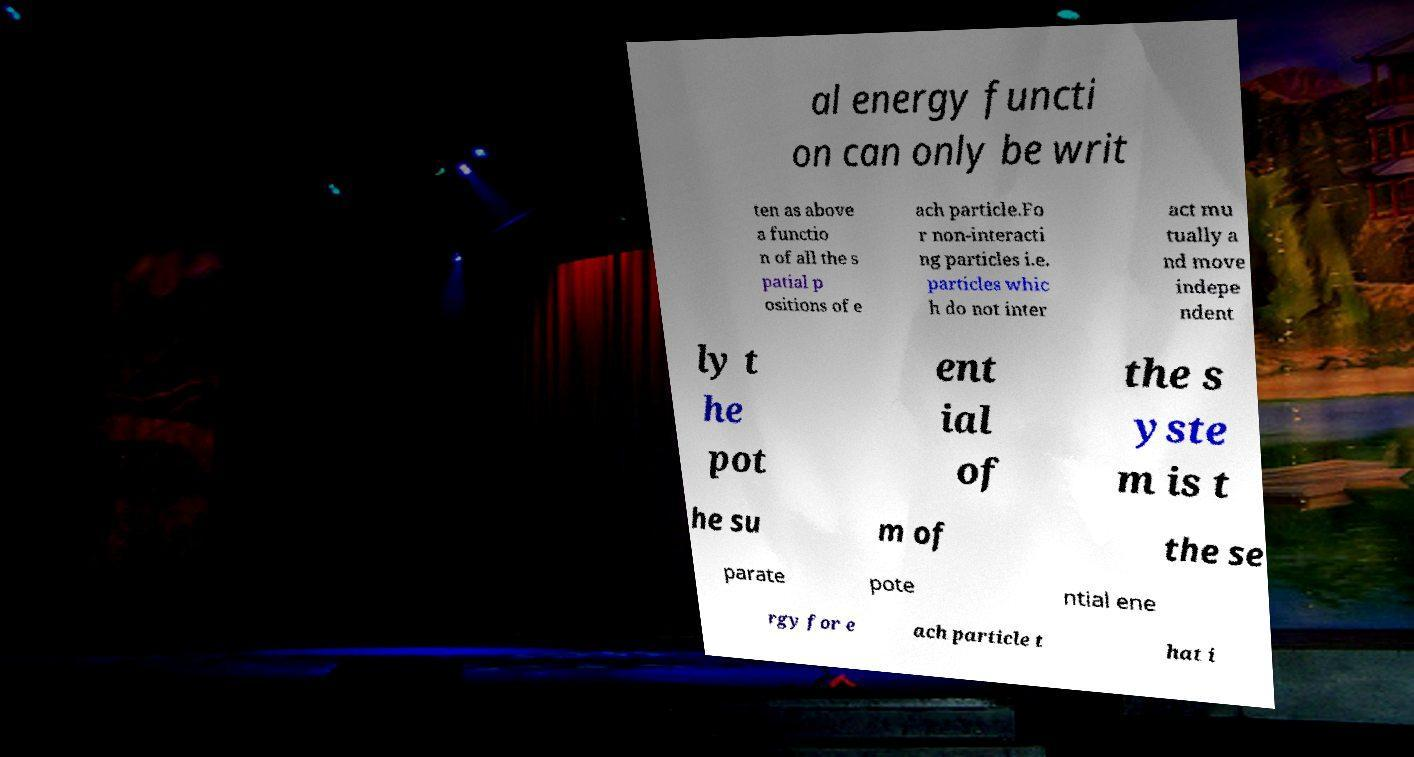Can you accurately transcribe the text from the provided image for me? al energy functi on can only be writ ten as above a functio n of all the s patial p ositions of e ach particle.Fo r non-interacti ng particles i.e. particles whic h do not inter act mu tually a nd move indepe ndent ly t he pot ent ial of the s yste m is t he su m of the se parate pote ntial ene rgy for e ach particle t hat i 